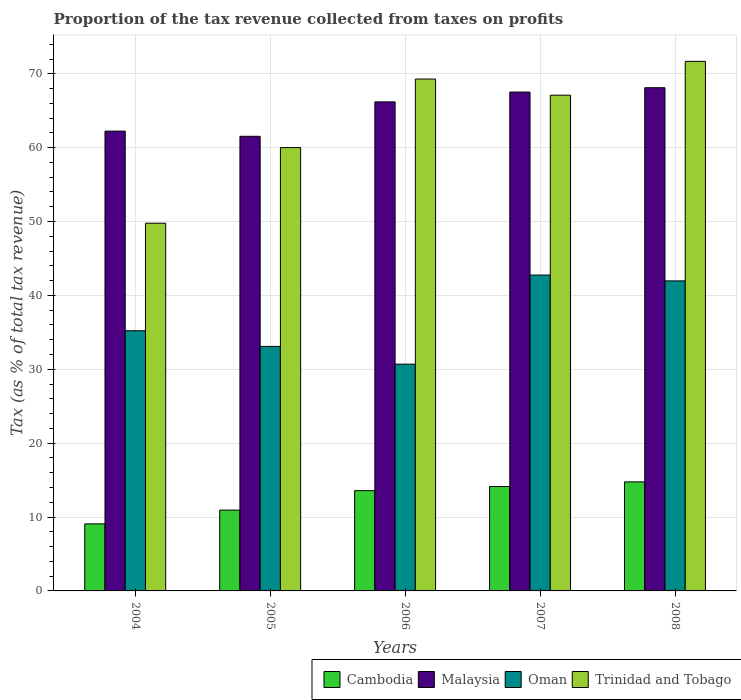Are the number of bars per tick equal to the number of legend labels?
Your answer should be compact. Yes. How many bars are there on the 1st tick from the left?
Provide a short and direct response. 4. How many bars are there on the 4th tick from the right?
Keep it short and to the point. 4. In how many cases, is the number of bars for a given year not equal to the number of legend labels?
Keep it short and to the point. 0. What is the proportion of the tax revenue collected in Cambodia in 2005?
Give a very brief answer. 10.94. Across all years, what is the maximum proportion of the tax revenue collected in Oman?
Your answer should be compact. 42.76. Across all years, what is the minimum proportion of the tax revenue collected in Trinidad and Tobago?
Your answer should be very brief. 49.77. In which year was the proportion of the tax revenue collected in Oman maximum?
Offer a terse response. 2007. In which year was the proportion of the tax revenue collected in Malaysia minimum?
Your answer should be compact. 2005. What is the total proportion of the tax revenue collected in Oman in the graph?
Your answer should be compact. 183.74. What is the difference between the proportion of the tax revenue collected in Cambodia in 2005 and that in 2006?
Make the answer very short. -2.63. What is the difference between the proportion of the tax revenue collected in Trinidad and Tobago in 2006 and the proportion of the tax revenue collected in Malaysia in 2004?
Keep it short and to the point. 7.05. What is the average proportion of the tax revenue collected in Trinidad and Tobago per year?
Provide a succinct answer. 63.57. In the year 2007, what is the difference between the proportion of the tax revenue collected in Cambodia and proportion of the tax revenue collected in Trinidad and Tobago?
Your response must be concise. -52.97. What is the ratio of the proportion of the tax revenue collected in Cambodia in 2006 to that in 2008?
Your response must be concise. 0.92. Is the proportion of the tax revenue collected in Malaysia in 2005 less than that in 2007?
Offer a very short reply. Yes. Is the difference between the proportion of the tax revenue collected in Cambodia in 2004 and 2008 greater than the difference between the proportion of the tax revenue collected in Trinidad and Tobago in 2004 and 2008?
Offer a very short reply. Yes. What is the difference between the highest and the second highest proportion of the tax revenue collected in Cambodia?
Your response must be concise. 0.63. What is the difference between the highest and the lowest proportion of the tax revenue collected in Malaysia?
Keep it short and to the point. 6.57. Is the sum of the proportion of the tax revenue collected in Malaysia in 2005 and 2006 greater than the maximum proportion of the tax revenue collected in Cambodia across all years?
Make the answer very short. Yes. What does the 1st bar from the left in 2007 represents?
Your response must be concise. Cambodia. What does the 1st bar from the right in 2008 represents?
Offer a terse response. Trinidad and Tobago. How many bars are there?
Offer a very short reply. 20. What is the difference between two consecutive major ticks on the Y-axis?
Provide a short and direct response. 10. Where does the legend appear in the graph?
Your answer should be compact. Bottom right. How many legend labels are there?
Give a very brief answer. 4. How are the legend labels stacked?
Give a very brief answer. Horizontal. What is the title of the graph?
Keep it short and to the point. Proportion of the tax revenue collected from taxes on profits. What is the label or title of the X-axis?
Keep it short and to the point. Years. What is the label or title of the Y-axis?
Offer a very short reply. Tax (as % of total tax revenue). What is the Tax (as % of total tax revenue) in Cambodia in 2004?
Give a very brief answer. 9.07. What is the Tax (as % of total tax revenue) in Malaysia in 2004?
Keep it short and to the point. 62.24. What is the Tax (as % of total tax revenue) in Oman in 2004?
Provide a short and direct response. 35.22. What is the Tax (as % of total tax revenue) in Trinidad and Tobago in 2004?
Your response must be concise. 49.77. What is the Tax (as % of total tax revenue) in Cambodia in 2005?
Make the answer very short. 10.94. What is the Tax (as % of total tax revenue) in Malaysia in 2005?
Your answer should be compact. 61.54. What is the Tax (as % of total tax revenue) in Oman in 2005?
Provide a short and direct response. 33.1. What is the Tax (as % of total tax revenue) of Trinidad and Tobago in 2005?
Your response must be concise. 60.01. What is the Tax (as % of total tax revenue) in Cambodia in 2006?
Provide a succinct answer. 13.57. What is the Tax (as % of total tax revenue) of Malaysia in 2006?
Provide a succinct answer. 66.2. What is the Tax (as % of total tax revenue) of Oman in 2006?
Provide a succinct answer. 30.7. What is the Tax (as % of total tax revenue) in Trinidad and Tobago in 2006?
Your answer should be compact. 69.29. What is the Tax (as % of total tax revenue) of Cambodia in 2007?
Provide a short and direct response. 14.13. What is the Tax (as % of total tax revenue) of Malaysia in 2007?
Your response must be concise. 67.53. What is the Tax (as % of total tax revenue) in Oman in 2007?
Offer a very short reply. 42.76. What is the Tax (as % of total tax revenue) in Trinidad and Tobago in 2007?
Provide a short and direct response. 67.1. What is the Tax (as % of total tax revenue) of Cambodia in 2008?
Keep it short and to the point. 14.76. What is the Tax (as % of total tax revenue) of Malaysia in 2008?
Provide a succinct answer. 68.11. What is the Tax (as % of total tax revenue) of Oman in 2008?
Make the answer very short. 41.97. What is the Tax (as % of total tax revenue) in Trinidad and Tobago in 2008?
Make the answer very short. 71.68. Across all years, what is the maximum Tax (as % of total tax revenue) of Cambodia?
Your answer should be compact. 14.76. Across all years, what is the maximum Tax (as % of total tax revenue) of Malaysia?
Ensure brevity in your answer.  68.11. Across all years, what is the maximum Tax (as % of total tax revenue) in Oman?
Keep it short and to the point. 42.76. Across all years, what is the maximum Tax (as % of total tax revenue) of Trinidad and Tobago?
Offer a terse response. 71.68. Across all years, what is the minimum Tax (as % of total tax revenue) in Cambodia?
Your answer should be compact. 9.07. Across all years, what is the minimum Tax (as % of total tax revenue) in Malaysia?
Your answer should be very brief. 61.54. Across all years, what is the minimum Tax (as % of total tax revenue) in Oman?
Your answer should be compact. 30.7. Across all years, what is the minimum Tax (as % of total tax revenue) in Trinidad and Tobago?
Provide a short and direct response. 49.77. What is the total Tax (as % of total tax revenue) in Cambodia in the graph?
Keep it short and to the point. 62.48. What is the total Tax (as % of total tax revenue) of Malaysia in the graph?
Offer a very short reply. 325.61. What is the total Tax (as % of total tax revenue) in Oman in the graph?
Offer a terse response. 183.74. What is the total Tax (as % of total tax revenue) in Trinidad and Tobago in the graph?
Provide a short and direct response. 317.86. What is the difference between the Tax (as % of total tax revenue) in Cambodia in 2004 and that in 2005?
Give a very brief answer. -1.86. What is the difference between the Tax (as % of total tax revenue) in Malaysia in 2004 and that in 2005?
Offer a terse response. 0.7. What is the difference between the Tax (as % of total tax revenue) in Oman in 2004 and that in 2005?
Offer a terse response. 2.13. What is the difference between the Tax (as % of total tax revenue) of Trinidad and Tobago in 2004 and that in 2005?
Offer a very short reply. -10.24. What is the difference between the Tax (as % of total tax revenue) in Cambodia in 2004 and that in 2006?
Keep it short and to the point. -4.5. What is the difference between the Tax (as % of total tax revenue) of Malaysia in 2004 and that in 2006?
Your answer should be compact. -3.96. What is the difference between the Tax (as % of total tax revenue) in Oman in 2004 and that in 2006?
Provide a short and direct response. 4.52. What is the difference between the Tax (as % of total tax revenue) of Trinidad and Tobago in 2004 and that in 2006?
Offer a terse response. -19.52. What is the difference between the Tax (as % of total tax revenue) in Cambodia in 2004 and that in 2007?
Ensure brevity in your answer.  -5.06. What is the difference between the Tax (as % of total tax revenue) in Malaysia in 2004 and that in 2007?
Give a very brief answer. -5.29. What is the difference between the Tax (as % of total tax revenue) in Oman in 2004 and that in 2007?
Keep it short and to the point. -7.53. What is the difference between the Tax (as % of total tax revenue) of Trinidad and Tobago in 2004 and that in 2007?
Offer a very short reply. -17.33. What is the difference between the Tax (as % of total tax revenue) in Cambodia in 2004 and that in 2008?
Keep it short and to the point. -5.69. What is the difference between the Tax (as % of total tax revenue) of Malaysia in 2004 and that in 2008?
Offer a very short reply. -5.87. What is the difference between the Tax (as % of total tax revenue) of Oman in 2004 and that in 2008?
Provide a short and direct response. -6.74. What is the difference between the Tax (as % of total tax revenue) in Trinidad and Tobago in 2004 and that in 2008?
Your answer should be very brief. -21.91. What is the difference between the Tax (as % of total tax revenue) of Cambodia in 2005 and that in 2006?
Your answer should be compact. -2.63. What is the difference between the Tax (as % of total tax revenue) of Malaysia in 2005 and that in 2006?
Offer a very short reply. -4.66. What is the difference between the Tax (as % of total tax revenue) of Oman in 2005 and that in 2006?
Your answer should be compact. 2.4. What is the difference between the Tax (as % of total tax revenue) of Trinidad and Tobago in 2005 and that in 2006?
Your answer should be compact. -9.28. What is the difference between the Tax (as % of total tax revenue) in Cambodia in 2005 and that in 2007?
Offer a terse response. -3.19. What is the difference between the Tax (as % of total tax revenue) of Malaysia in 2005 and that in 2007?
Offer a very short reply. -5.99. What is the difference between the Tax (as % of total tax revenue) of Oman in 2005 and that in 2007?
Offer a terse response. -9.66. What is the difference between the Tax (as % of total tax revenue) of Trinidad and Tobago in 2005 and that in 2007?
Provide a succinct answer. -7.09. What is the difference between the Tax (as % of total tax revenue) of Cambodia in 2005 and that in 2008?
Offer a terse response. -3.82. What is the difference between the Tax (as % of total tax revenue) of Malaysia in 2005 and that in 2008?
Ensure brevity in your answer.  -6.57. What is the difference between the Tax (as % of total tax revenue) of Oman in 2005 and that in 2008?
Your answer should be very brief. -8.87. What is the difference between the Tax (as % of total tax revenue) of Trinidad and Tobago in 2005 and that in 2008?
Keep it short and to the point. -11.67. What is the difference between the Tax (as % of total tax revenue) in Cambodia in 2006 and that in 2007?
Offer a terse response. -0.56. What is the difference between the Tax (as % of total tax revenue) in Malaysia in 2006 and that in 2007?
Offer a very short reply. -1.33. What is the difference between the Tax (as % of total tax revenue) of Oman in 2006 and that in 2007?
Make the answer very short. -12.06. What is the difference between the Tax (as % of total tax revenue) of Trinidad and Tobago in 2006 and that in 2007?
Ensure brevity in your answer.  2.19. What is the difference between the Tax (as % of total tax revenue) in Cambodia in 2006 and that in 2008?
Offer a very short reply. -1.19. What is the difference between the Tax (as % of total tax revenue) of Malaysia in 2006 and that in 2008?
Your answer should be very brief. -1.92. What is the difference between the Tax (as % of total tax revenue) in Oman in 2006 and that in 2008?
Ensure brevity in your answer.  -11.27. What is the difference between the Tax (as % of total tax revenue) of Trinidad and Tobago in 2006 and that in 2008?
Give a very brief answer. -2.39. What is the difference between the Tax (as % of total tax revenue) in Cambodia in 2007 and that in 2008?
Keep it short and to the point. -0.63. What is the difference between the Tax (as % of total tax revenue) of Malaysia in 2007 and that in 2008?
Your response must be concise. -0.59. What is the difference between the Tax (as % of total tax revenue) in Oman in 2007 and that in 2008?
Provide a short and direct response. 0.79. What is the difference between the Tax (as % of total tax revenue) in Trinidad and Tobago in 2007 and that in 2008?
Provide a succinct answer. -4.58. What is the difference between the Tax (as % of total tax revenue) in Cambodia in 2004 and the Tax (as % of total tax revenue) in Malaysia in 2005?
Offer a very short reply. -52.46. What is the difference between the Tax (as % of total tax revenue) of Cambodia in 2004 and the Tax (as % of total tax revenue) of Oman in 2005?
Provide a succinct answer. -24.02. What is the difference between the Tax (as % of total tax revenue) of Cambodia in 2004 and the Tax (as % of total tax revenue) of Trinidad and Tobago in 2005?
Your answer should be compact. -50.94. What is the difference between the Tax (as % of total tax revenue) in Malaysia in 2004 and the Tax (as % of total tax revenue) in Oman in 2005?
Ensure brevity in your answer.  29.14. What is the difference between the Tax (as % of total tax revenue) of Malaysia in 2004 and the Tax (as % of total tax revenue) of Trinidad and Tobago in 2005?
Provide a succinct answer. 2.23. What is the difference between the Tax (as % of total tax revenue) of Oman in 2004 and the Tax (as % of total tax revenue) of Trinidad and Tobago in 2005?
Your answer should be very brief. -24.79. What is the difference between the Tax (as % of total tax revenue) in Cambodia in 2004 and the Tax (as % of total tax revenue) in Malaysia in 2006?
Keep it short and to the point. -57.12. What is the difference between the Tax (as % of total tax revenue) of Cambodia in 2004 and the Tax (as % of total tax revenue) of Oman in 2006?
Provide a short and direct response. -21.62. What is the difference between the Tax (as % of total tax revenue) of Cambodia in 2004 and the Tax (as % of total tax revenue) of Trinidad and Tobago in 2006?
Give a very brief answer. -60.21. What is the difference between the Tax (as % of total tax revenue) in Malaysia in 2004 and the Tax (as % of total tax revenue) in Oman in 2006?
Ensure brevity in your answer.  31.54. What is the difference between the Tax (as % of total tax revenue) in Malaysia in 2004 and the Tax (as % of total tax revenue) in Trinidad and Tobago in 2006?
Make the answer very short. -7.05. What is the difference between the Tax (as % of total tax revenue) of Oman in 2004 and the Tax (as % of total tax revenue) of Trinidad and Tobago in 2006?
Your response must be concise. -34.07. What is the difference between the Tax (as % of total tax revenue) in Cambodia in 2004 and the Tax (as % of total tax revenue) in Malaysia in 2007?
Ensure brevity in your answer.  -58.45. What is the difference between the Tax (as % of total tax revenue) in Cambodia in 2004 and the Tax (as % of total tax revenue) in Oman in 2007?
Provide a short and direct response. -33.68. What is the difference between the Tax (as % of total tax revenue) in Cambodia in 2004 and the Tax (as % of total tax revenue) in Trinidad and Tobago in 2007?
Your answer should be compact. -58.03. What is the difference between the Tax (as % of total tax revenue) in Malaysia in 2004 and the Tax (as % of total tax revenue) in Oman in 2007?
Ensure brevity in your answer.  19.48. What is the difference between the Tax (as % of total tax revenue) in Malaysia in 2004 and the Tax (as % of total tax revenue) in Trinidad and Tobago in 2007?
Offer a very short reply. -4.87. What is the difference between the Tax (as % of total tax revenue) of Oman in 2004 and the Tax (as % of total tax revenue) of Trinidad and Tobago in 2007?
Your response must be concise. -31.88. What is the difference between the Tax (as % of total tax revenue) in Cambodia in 2004 and the Tax (as % of total tax revenue) in Malaysia in 2008?
Make the answer very short. -59.04. What is the difference between the Tax (as % of total tax revenue) of Cambodia in 2004 and the Tax (as % of total tax revenue) of Oman in 2008?
Your response must be concise. -32.89. What is the difference between the Tax (as % of total tax revenue) in Cambodia in 2004 and the Tax (as % of total tax revenue) in Trinidad and Tobago in 2008?
Provide a short and direct response. -62.61. What is the difference between the Tax (as % of total tax revenue) in Malaysia in 2004 and the Tax (as % of total tax revenue) in Oman in 2008?
Ensure brevity in your answer.  20.27. What is the difference between the Tax (as % of total tax revenue) in Malaysia in 2004 and the Tax (as % of total tax revenue) in Trinidad and Tobago in 2008?
Ensure brevity in your answer.  -9.44. What is the difference between the Tax (as % of total tax revenue) of Oman in 2004 and the Tax (as % of total tax revenue) of Trinidad and Tobago in 2008?
Ensure brevity in your answer.  -36.46. What is the difference between the Tax (as % of total tax revenue) of Cambodia in 2005 and the Tax (as % of total tax revenue) of Malaysia in 2006?
Ensure brevity in your answer.  -55.26. What is the difference between the Tax (as % of total tax revenue) of Cambodia in 2005 and the Tax (as % of total tax revenue) of Oman in 2006?
Make the answer very short. -19.76. What is the difference between the Tax (as % of total tax revenue) of Cambodia in 2005 and the Tax (as % of total tax revenue) of Trinidad and Tobago in 2006?
Provide a short and direct response. -58.35. What is the difference between the Tax (as % of total tax revenue) in Malaysia in 2005 and the Tax (as % of total tax revenue) in Oman in 2006?
Offer a terse response. 30.84. What is the difference between the Tax (as % of total tax revenue) in Malaysia in 2005 and the Tax (as % of total tax revenue) in Trinidad and Tobago in 2006?
Offer a very short reply. -7.75. What is the difference between the Tax (as % of total tax revenue) in Oman in 2005 and the Tax (as % of total tax revenue) in Trinidad and Tobago in 2006?
Offer a terse response. -36.19. What is the difference between the Tax (as % of total tax revenue) in Cambodia in 2005 and the Tax (as % of total tax revenue) in Malaysia in 2007?
Your response must be concise. -56.59. What is the difference between the Tax (as % of total tax revenue) in Cambodia in 2005 and the Tax (as % of total tax revenue) in Oman in 2007?
Offer a terse response. -31.82. What is the difference between the Tax (as % of total tax revenue) of Cambodia in 2005 and the Tax (as % of total tax revenue) of Trinidad and Tobago in 2007?
Offer a very short reply. -56.16. What is the difference between the Tax (as % of total tax revenue) of Malaysia in 2005 and the Tax (as % of total tax revenue) of Oman in 2007?
Offer a terse response. 18.78. What is the difference between the Tax (as % of total tax revenue) in Malaysia in 2005 and the Tax (as % of total tax revenue) in Trinidad and Tobago in 2007?
Your response must be concise. -5.57. What is the difference between the Tax (as % of total tax revenue) in Oman in 2005 and the Tax (as % of total tax revenue) in Trinidad and Tobago in 2007?
Give a very brief answer. -34.01. What is the difference between the Tax (as % of total tax revenue) in Cambodia in 2005 and the Tax (as % of total tax revenue) in Malaysia in 2008?
Provide a short and direct response. -57.17. What is the difference between the Tax (as % of total tax revenue) of Cambodia in 2005 and the Tax (as % of total tax revenue) of Oman in 2008?
Offer a very short reply. -31.03. What is the difference between the Tax (as % of total tax revenue) of Cambodia in 2005 and the Tax (as % of total tax revenue) of Trinidad and Tobago in 2008?
Ensure brevity in your answer.  -60.74. What is the difference between the Tax (as % of total tax revenue) in Malaysia in 2005 and the Tax (as % of total tax revenue) in Oman in 2008?
Offer a terse response. 19.57. What is the difference between the Tax (as % of total tax revenue) of Malaysia in 2005 and the Tax (as % of total tax revenue) of Trinidad and Tobago in 2008?
Offer a terse response. -10.14. What is the difference between the Tax (as % of total tax revenue) in Oman in 2005 and the Tax (as % of total tax revenue) in Trinidad and Tobago in 2008?
Offer a very short reply. -38.59. What is the difference between the Tax (as % of total tax revenue) in Cambodia in 2006 and the Tax (as % of total tax revenue) in Malaysia in 2007?
Offer a very short reply. -53.95. What is the difference between the Tax (as % of total tax revenue) of Cambodia in 2006 and the Tax (as % of total tax revenue) of Oman in 2007?
Your answer should be compact. -29.18. What is the difference between the Tax (as % of total tax revenue) of Cambodia in 2006 and the Tax (as % of total tax revenue) of Trinidad and Tobago in 2007?
Offer a very short reply. -53.53. What is the difference between the Tax (as % of total tax revenue) of Malaysia in 2006 and the Tax (as % of total tax revenue) of Oman in 2007?
Keep it short and to the point. 23.44. What is the difference between the Tax (as % of total tax revenue) in Malaysia in 2006 and the Tax (as % of total tax revenue) in Trinidad and Tobago in 2007?
Your response must be concise. -0.91. What is the difference between the Tax (as % of total tax revenue) of Oman in 2006 and the Tax (as % of total tax revenue) of Trinidad and Tobago in 2007?
Give a very brief answer. -36.41. What is the difference between the Tax (as % of total tax revenue) in Cambodia in 2006 and the Tax (as % of total tax revenue) in Malaysia in 2008?
Offer a very short reply. -54.54. What is the difference between the Tax (as % of total tax revenue) of Cambodia in 2006 and the Tax (as % of total tax revenue) of Oman in 2008?
Provide a short and direct response. -28.39. What is the difference between the Tax (as % of total tax revenue) in Cambodia in 2006 and the Tax (as % of total tax revenue) in Trinidad and Tobago in 2008?
Ensure brevity in your answer.  -58.11. What is the difference between the Tax (as % of total tax revenue) in Malaysia in 2006 and the Tax (as % of total tax revenue) in Oman in 2008?
Keep it short and to the point. 24.23. What is the difference between the Tax (as % of total tax revenue) in Malaysia in 2006 and the Tax (as % of total tax revenue) in Trinidad and Tobago in 2008?
Make the answer very short. -5.49. What is the difference between the Tax (as % of total tax revenue) of Oman in 2006 and the Tax (as % of total tax revenue) of Trinidad and Tobago in 2008?
Provide a short and direct response. -40.99. What is the difference between the Tax (as % of total tax revenue) of Cambodia in 2007 and the Tax (as % of total tax revenue) of Malaysia in 2008?
Ensure brevity in your answer.  -53.98. What is the difference between the Tax (as % of total tax revenue) in Cambodia in 2007 and the Tax (as % of total tax revenue) in Oman in 2008?
Your answer should be very brief. -27.83. What is the difference between the Tax (as % of total tax revenue) of Cambodia in 2007 and the Tax (as % of total tax revenue) of Trinidad and Tobago in 2008?
Make the answer very short. -57.55. What is the difference between the Tax (as % of total tax revenue) in Malaysia in 2007 and the Tax (as % of total tax revenue) in Oman in 2008?
Give a very brief answer. 25.56. What is the difference between the Tax (as % of total tax revenue) of Malaysia in 2007 and the Tax (as % of total tax revenue) of Trinidad and Tobago in 2008?
Your response must be concise. -4.16. What is the difference between the Tax (as % of total tax revenue) in Oman in 2007 and the Tax (as % of total tax revenue) in Trinidad and Tobago in 2008?
Provide a short and direct response. -28.93. What is the average Tax (as % of total tax revenue) of Cambodia per year?
Make the answer very short. 12.5. What is the average Tax (as % of total tax revenue) of Malaysia per year?
Your answer should be very brief. 65.12. What is the average Tax (as % of total tax revenue) of Oman per year?
Offer a very short reply. 36.75. What is the average Tax (as % of total tax revenue) in Trinidad and Tobago per year?
Keep it short and to the point. 63.57. In the year 2004, what is the difference between the Tax (as % of total tax revenue) in Cambodia and Tax (as % of total tax revenue) in Malaysia?
Ensure brevity in your answer.  -53.16. In the year 2004, what is the difference between the Tax (as % of total tax revenue) in Cambodia and Tax (as % of total tax revenue) in Oman?
Offer a very short reply. -26.15. In the year 2004, what is the difference between the Tax (as % of total tax revenue) in Cambodia and Tax (as % of total tax revenue) in Trinidad and Tobago?
Provide a succinct answer. -40.7. In the year 2004, what is the difference between the Tax (as % of total tax revenue) in Malaysia and Tax (as % of total tax revenue) in Oman?
Your answer should be very brief. 27.02. In the year 2004, what is the difference between the Tax (as % of total tax revenue) of Malaysia and Tax (as % of total tax revenue) of Trinidad and Tobago?
Provide a succinct answer. 12.47. In the year 2004, what is the difference between the Tax (as % of total tax revenue) of Oman and Tax (as % of total tax revenue) of Trinidad and Tobago?
Provide a succinct answer. -14.55. In the year 2005, what is the difference between the Tax (as % of total tax revenue) of Cambodia and Tax (as % of total tax revenue) of Malaysia?
Ensure brevity in your answer.  -50.6. In the year 2005, what is the difference between the Tax (as % of total tax revenue) of Cambodia and Tax (as % of total tax revenue) of Oman?
Offer a very short reply. -22.16. In the year 2005, what is the difference between the Tax (as % of total tax revenue) of Cambodia and Tax (as % of total tax revenue) of Trinidad and Tobago?
Keep it short and to the point. -49.07. In the year 2005, what is the difference between the Tax (as % of total tax revenue) in Malaysia and Tax (as % of total tax revenue) in Oman?
Make the answer very short. 28.44. In the year 2005, what is the difference between the Tax (as % of total tax revenue) of Malaysia and Tax (as % of total tax revenue) of Trinidad and Tobago?
Your answer should be compact. 1.53. In the year 2005, what is the difference between the Tax (as % of total tax revenue) of Oman and Tax (as % of total tax revenue) of Trinidad and Tobago?
Keep it short and to the point. -26.92. In the year 2006, what is the difference between the Tax (as % of total tax revenue) in Cambodia and Tax (as % of total tax revenue) in Malaysia?
Your response must be concise. -52.62. In the year 2006, what is the difference between the Tax (as % of total tax revenue) in Cambodia and Tax (as % of total tax revenue) in Oman?
Give a very brief answer. -17.12. In the year 2006, what is the difference between the Tax (as % of total tax revenue) in Cambodia and Tax (as % of total tax revenue) in Trinidad and Tobago?
Offer a very short reply. -55.72. In the year 2006, what is the difference between the Tax (as % of total tax revenue) of Malaysia and Tax (as % of total tax revenue) of Oman?
Offer a very short reply. 35.5. In the year 2006, what is the difference between the Tax (as % of total tax revenue) in Malaysia and Tax (as % of total tax revenue) in Trinidad and Tobago?
Your response must be concise. -3.09. In the year 2006, what is the difference between the Tax (as % of total tax revenue) in Oman and Tax (as % of total tax revenue) in Trinidad and Tobago?
Offer a terse response. -38.59. In the year 2007, what is the difference between the Tax (as % of total tax revenue) of Cambodia and Tax (as % of total tax revenue) of Malaysia?
Ensure brevity in your answer.  -53.39. In the year 2007, what is the difference between the Tax (as % of total tax revenue) of Cambodia and Tax (as % of total tax revenue) of Oman?
Offer a very short reply. -28.62. In the year 2007, what is the difference between the Tax (as % of total tax revenue) of Cambodia and Tax (as % of total tax revenue) of Trinidad and Tobago?
Offer a very short reply. -52.97. In the year 2007, what is the difference between the Tax (as % of total tax revenue) in Malaysia and Tax (as % of total tax revenue) in Oman?
Ensure brevity in your answer.  24.77. In the year 2007, what is the difference between the Tax (as % of total tax revenue) in Malaysia and Tax (as % of total tax revenue) in Trinidad and Tobago?
Offer a terse response. 0.42. In the year 2007, what is the difference between the Tax (as % of total tax revenue) in Oman and Tax (as % of total tax revenue) in Trinidad and Tobago?
Ensure brevity in your answer.  -24.35. In the year 2008, what is the difference between the Tax (as % of total tax revenue) in Cambodia and Tax (as % of total tax revenue) in Malaysia?
Your answer should be compact. -53.35. In the year 2008, what is the difference between the Tax (as % of total tax revenue) of Cambodia and Tax (as % of total tax revenue) of Oman?
Provide a succinct answer. -27.2. In the year 2008, what is the difference between the Tax (as % of total tax revenue) in Cambodia and Tax (as % of total tax revenue) in Trinidad and Tobago?
Offer a terse response. -56.92. In the year 2008, what is the difference between the Tax (as % of total tax revenue) of Malaysia and Tax (as % of total tax revenue) of Oman?
Give a very brief answer. 26.15. In the year 2008, what is the difference between the Tax (as % of total tax revenue) in Malaysia and Tax (as % of total tax revenue) in Trinidad and Tobago?
Ensure brevity in your answer.  -3.57. In the year 2008, what is the difference between the Tax (as % of total tax revenue) in Oman and Tax (as % of total tax revenue) in Trinidad and Tobago?
Give a very brief answer. -29.72. What is the ratio of the Tax (as % of total tax revenue) in Cambodia in 2004 to that in 2005?
Provide a short and direct response. 0.83. What is the ratio of the Tax (as % of total tax revenue) of Malaysia in 2004 to that in 2005?
Provide a succinct answer. 1.01. What is the ratio of the Tax (as % of total tax revenue) of Oman in 2004 to that in 2005?
Your answer should be compact. 1.06. What is the ratio of the Tax (as % of total tax revenue) in Trinidad and Tobago in 2004 to that in 2005?
Your response must be concise. 0.83. What is the ratio of the Tax (as % of total tax revenue) of Cambodia in 2004 to that in 2006?
Provide a succinct answer. 0.67. What is the ratio of the Tax (as % of total tax revenue) of Malaysia in 2004 to that in 2006?
Keep it short and to the point. 0.94. What is the ratio of the Tax (as % of total tax revenue) in Oman in 2004 to that in 2006?
Offer a very short reply. 1.15. What is the ratio of the Tax (as % of total tax revenue) of Trinidad and Tobago in 2004 to that in 2006?
Your response must be concise. 0.72. What is the ratio of the Tax (as % of total tax revenue) of Cambodia in 2004 to that in 2007?
Give a very brief answer. 0.64. What is the ratio of the Tax (as % of total tax revenue) in Malaysia in 2004 to that in 2007?
Your answer should be very brief. 0.92. What is the ratio of the Tax (as % of total tax revenue) of Oman in 2004 to that in 2007?
Your answer should be compact. 0.82. What is the ratio of the Tax (as % of total tax revenue) of Trinidad and Tobago in 2004 to that in 2007?
Make the answer very short. 0.74. What is the ratio of the Tax (as % of total tax revenue) in Cambodia in 2004 to that in 2008?
Offer a very short reply. 0.61. What is the ratio of the Tax (as % of total tax revenue) of Malaysia in 2004 to that in 2008?
Offer a very short reply. 0.91. What is the ratio of the Tax (as % of total tax revenue) in Oman in 2004 to that in 2008?
Keep it short and to the point. 0.84. What is the ratio of the Tax (as % of total tax revenue) in Trinidad and Tobago in 2004 to that in 2008?
Offer a very short reply. 0.69. What is the ratio of the Tax (as % of total tax revenue) in Cambodia in 2005 to that in 2006?
Offer a very short reply. 0.81. What is the ratio of the Tax (as % of total tax revenue) of Malaysia in 2005 to that in 2006?
Provide a succinct answer. 0.93. What is the ratio of the Tax (as % of total tax revenue) of Oman in 2005 to that in 2006?
Give a very brief answer. 1.08. What is the ratio of the Tax (as % of total tax revenue) of Trinidad and Tobago in 2005 to that in 2006?
Ensure brevity in your answer.  0.87. What is the ratio of the Tax (as % of total tax revenue) of Cambodia in 2005 to that in 2007?
Offer a very short reply. 0.77. What is the ratio of the Tax (as % of total tax revenue) in Malaysia in 2005 to that in 2007?
Your answer should be compact. 0.91. What is the ratio of the Tax (as % of total tax revenue) in Oman in 2005 to that in 2007?
Give a very brief answer. 0.77. What is the ratio of the Tax (as % of total tax revenue) in Trinidad and Tobago in 2005 to that in 2007?
Provide a short and direct response. 0.89. What is the ratio of the Tax (as % of total tax revenue) of Cambodia in 2005 to that in 2008?
Offer a very short reply. 0.74. What is the ratio of the Tax (as % of total tax revenue) in Malaysia in 2005 to that in 2008?
Ensure brevity in your answer.  0.9. What is the ratio of the Tax (as % of total tax revenue) of Oman in 2005 to that in 2008?
Your response must be concise. 0.79. What is the ratio of the Tax (as % of total tax revenue) of Trinidad and Tobago in 2005 to that in 2008?
Offer a terse response. 0.84. What is the ratio of the Tax (as % of total tax revenue) of Cambodia in 2006 to that in 2007?
Your answer should be very brief. 0.96. What is the ratio of the Tax (as % of total tax revenue) in Malaysia in 2006 to that in 2007?
Make the answer very short. 0.98. What is the ratio of the Tax (as % of total tax revenue) in Oman in 2006 to that in 2007?
Keep it short and to the point. 0.72. What is the ratio of the Tax (as % of total tax revenue) in Trinidad and Tobago in 2006 to that in 2007?
Keep it short and to the point. 1.03. What is the ratio of the Tax (as % of total tax revenue) of Cambodia in 2006 to that in 2008?
Give a very brief answer. 0.92. What is the ratio of the Tax (as % of total tax revenue) of Malaysia in 2006 to that in 2008?
Keep it short and to the point. 0.97. What is the ratio of the Tax (as % of total tax revenue) in Oman in 2006 to that in 2008?
Your response must be concise. 0.73. What is the ratio of the Tax (as % of total tax revenue) of Trinidad and Tobago in 2006 to that in 2008?
Make the answer very short. 0.97. What is the ratio of the Tax (as % of total tax revenue) in Cambodia in 2007 to that in 2008?
Your answer should be very brief. 0.96. What is the ratio of the Tax (as % of total tax revenue) in Malaysia in 2007 to that in 2008?
Make the answer very short. 0.99. What is the ratio of the Tax (as % of total tax revenue) in Oman in 2007 to that in 2008?
Your response must be concise. 1.02. What is the ratio of the Tax (as % of total tax revenue) of Trinidad and Tobago in 2007 to that in 2008?
Your answer should be very brief. 0.94. What is the difference between the highest and the second highest Tax (as % of total tax revenue) of Cambodia?
Your answer should be compact. 0.63. What is the difference between the highest and the second highest Tax (as % of total tax revenue) of Malaysia?
Your answer should be compact. 0.59. What is the difference between the highest and the second highest Tax (as % of total tax revenue) of Oman?
Provide a short and direct response. 0.79. What is the difference between the highest and the second highest Tax (as % of total tax revenue) in Trinidad and Tobago?
Offer a very short reply. 2.39. What is the difference between the highest and the lowest Tax (as % of total tax revenue) in Cambodia?
Offer a terse response. 5.69. What is the difference between the highest and the lowest Tax (as % of total tax revenue) in Malaysia?
Your response must be concise. 6.57. What is the difference between the highest and the lowest Tax (as % of total tax revenue) in Oman?
Offer a very short reply. 12.06. What is the difference between the highest and the lowest Tax (as % of total tax revenue) in Trinidad and Tobago?
Make the answer very short. 21.91. 